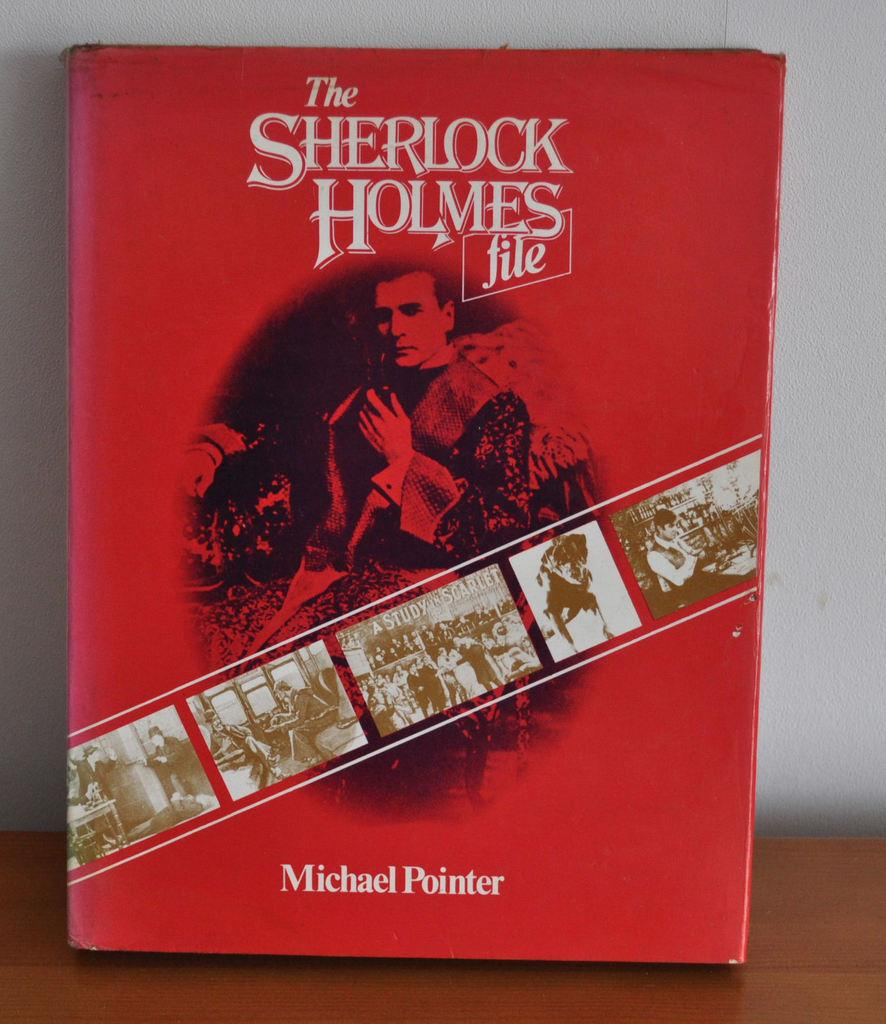<image>
Relay a brief, clear account of the picture shown. The red cover of a Sherlock Holmes book 